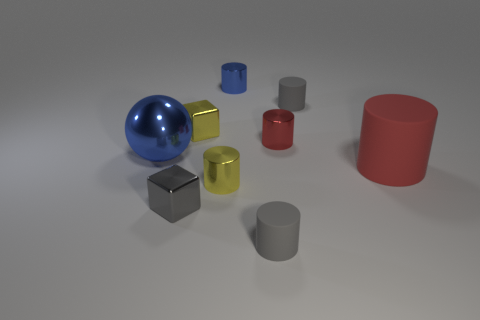Subtract 1 cylinders. How many cylinders are left? 5 Subtract all blue cylinders. How many cylinders are left? 5 Subtract all yellow cylinders. How many cylinders are left? 5 Subtract all cyan cylinders. Subtract all green spheres. How many cylinders are left? 6 Add 1 purple matte objects. How many objects exist? 10 Subtract all balls. How many objects are left? 8 Add 7 gray metallic objects. How many gray metallic objects are left? 8 Add 7 red matte things. How many red matte things exist? 8 Subtract 0 cyan cylinders. How many objects are left? 9 Subtract all yellow shiny balls. Subtract all red things. How many objects are left? 7 